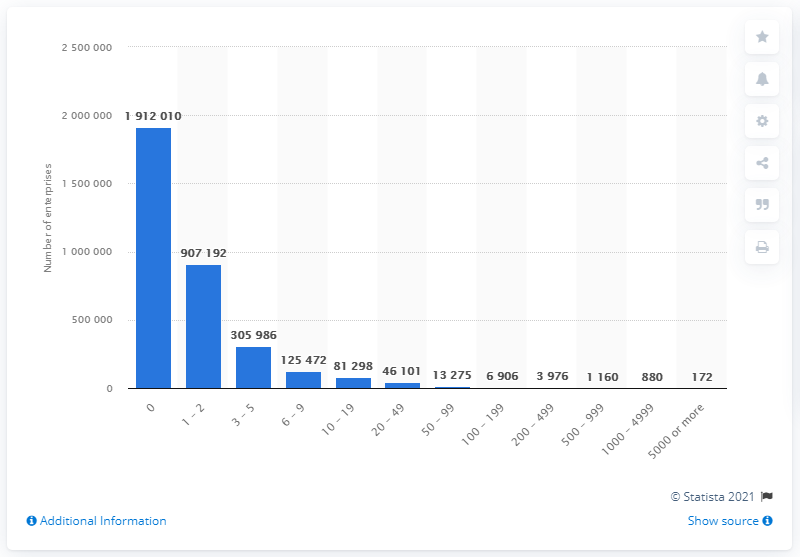Indicate a few pertinent items in this graphic. As of 2020, there were 191,201 to 1,000,000 companies in Spain with no employees. In 2020, there were 172 companies in the United States that had 5,000 or more employees. 